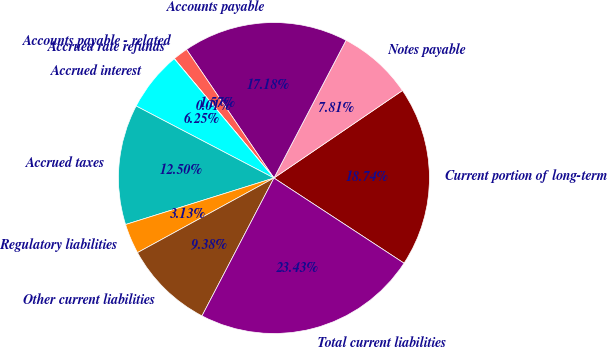<chart> <loc_0><loc_0><loc_500><loc_500><pie_chart><fcel>Current portion of long-term<fcel>Notes payable<fcel>Accounts payable<fcel>Accounts payable - related<fcel>Accrued rate refunds<fcel>Accrued interest<fcel>Accrued taxes<fcel>Regulatory liabilities<fcel>Other current liabilities<fcel>Total current liabilities<nl><fcel>18.74%<fcel>7.81%<fcel>17.18%<fcel>1.57%<fcel>0.01%<fcel>6.25%<fcel>12.5%<fcel>3.13%<fcel>9.38%<fcel>23.43%<nl></chart> 